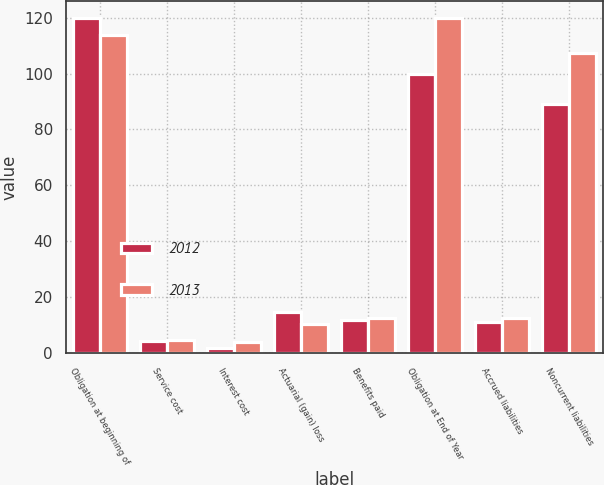<chart> <loc_0><loc_0><loc_500><loc_500><stacked_bar_chart><ecel><fcel>Obligation at beginning of<fcel>Service cost<fcel>Interest cost<fcel>Actuarial (gain) loss<fcel>Benefits paid<fcel>Obligation at End of Year<fcel>Accrued liabilities<fcel>Noncurrent liabilities<nl><fcel>2012<fcel>119.9<fcel>4.3<fcel>1.9<fcel>14.5<fcel>11.7<fcel>99.9<fcel>10.9<fcel>89<nl><fcel>2013<fcel>113.8<fcel>4.5<fcel>3.9<fcel>10.2<fcel>12.5<fcel>119.9<fcel>12.6<fcel>107.3<nl></chart> 